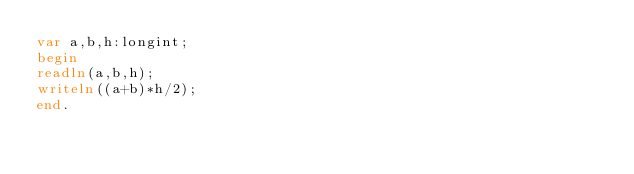<code> <loc_0><loc_0><loc_500><loc_500><_Pascal_>var a,b,h:longint;
begin
readln(a,b,h);
writeln((a+b)*h/2);
end.</code> 